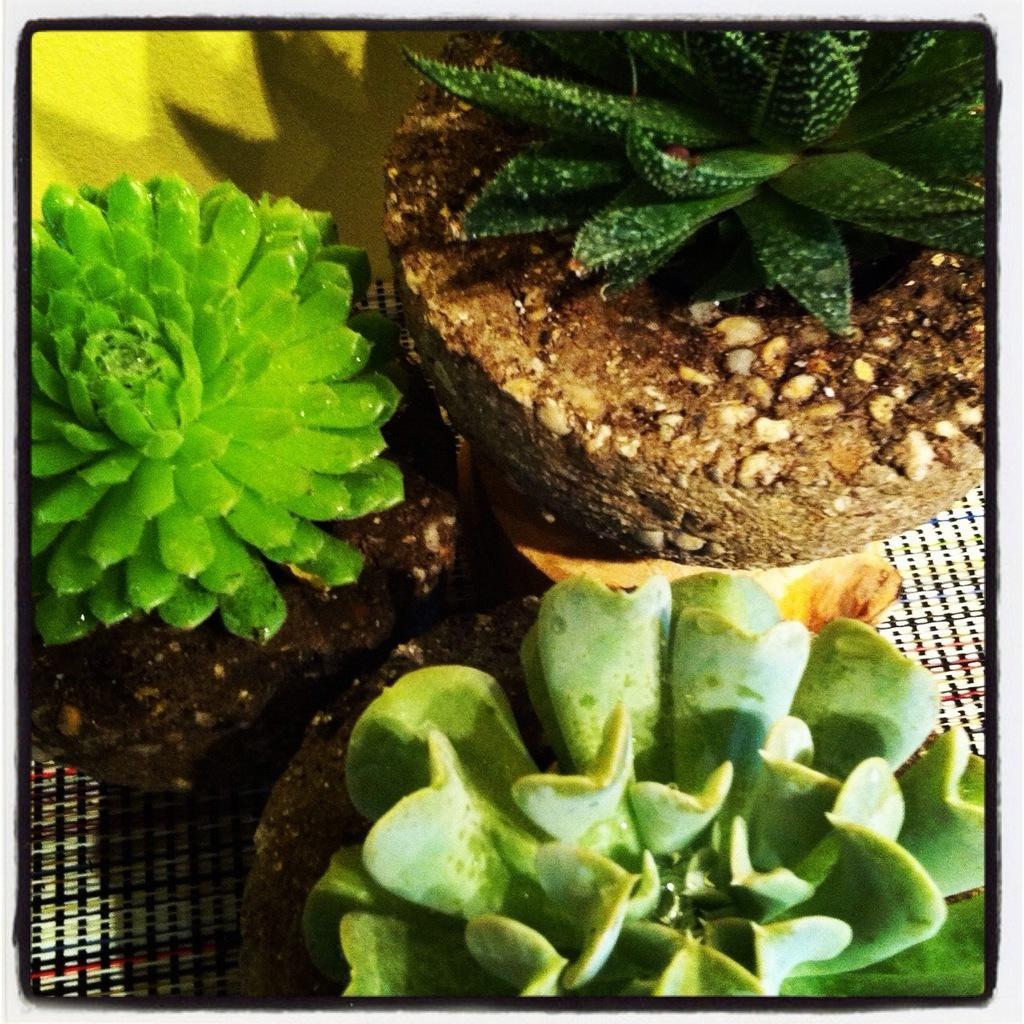Describe this image in one or two sentences. This is an edited image with the borders. In the center we can see there are some objects seems to be the succulent plants. In the background we can see some other objects. 